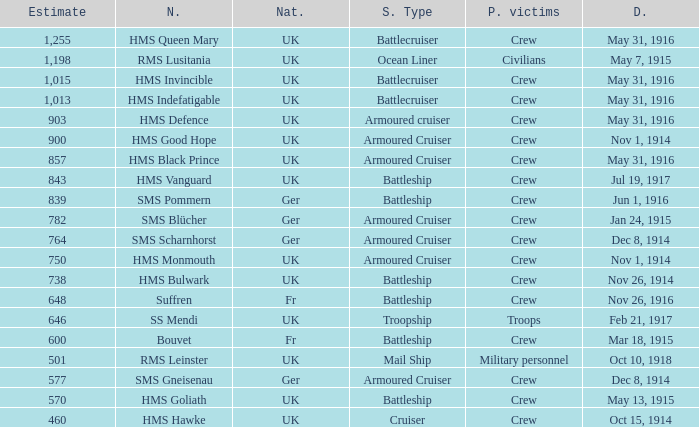What is the nationality of the ship when the principle victims are civilians? UK. 